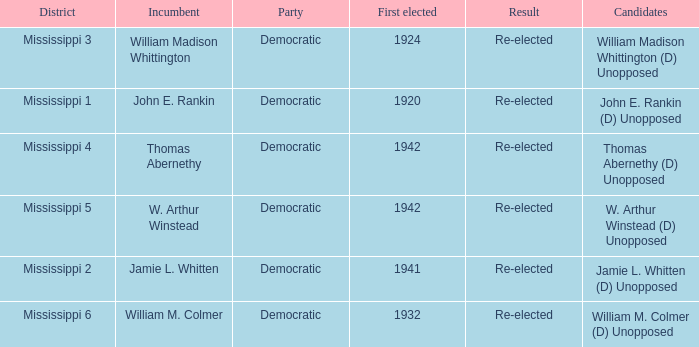What is the result for w. arthur winstead? Re-elected. 